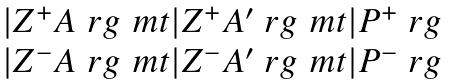Convert formula to latex. <formula><loc_0><loc_0><loc_500><loc_500>\begin{array} { c } | Z ^ { + } A \ r g \ m t | Z ^ { + } A ^ { \prime } \ r g \ m t | P ^ { + } \ r g \\ | Z ^ { - } A \ r g \ m t | Z ^ { - } A ^ { \prime } \ r g \ m t | P ^ { - } \ r g \\ \end{array}</formula> 